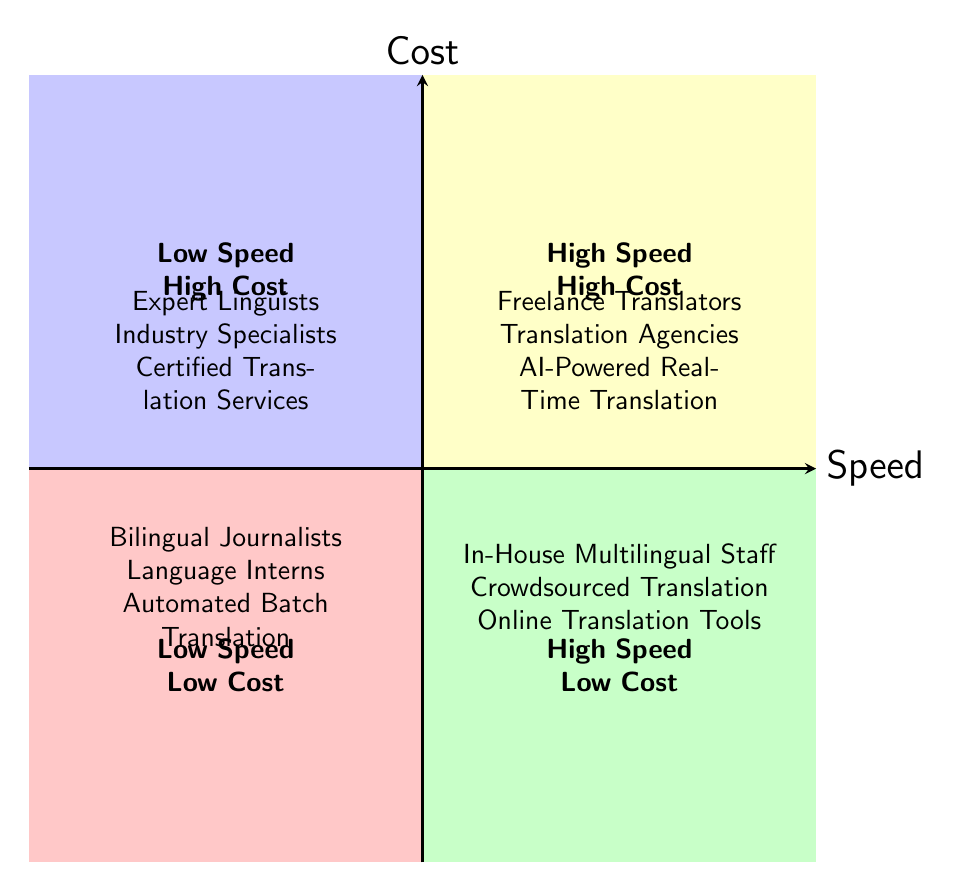What categories are in the High Speed - Low Cost quadrant? The High Speed - Low Cost quadrant contains three categories: In-House Multilingual Staff, Crowdsourced Translation, and Online Translation Tools. This is determined by the provided data for that specific quadrant.
Answer: In-House Multilingual Staff, Crowdsourced Translation, Online Translation Tools Which quadrant contains Expert Linguists? Expert Linguists are located in the Low Speed - High Cost quadrant. This can be derived from the data provided, as Expert Linguists only appear in the Low Speed - High Cost section.
Answer: Low Speed - High Cost How many categories are in the High Speed - High Cost quadrant? The High Speed - High Cost quadrant has three categories: Freelance Translators, Translation Agencies, and AI-Powered Real-Time Translation. Counting these, we can confirm the total is three.
Answer: 3 What is the main difference between the Low Cost quadrants? The main difference is speed: the Low Speed - Low Cost quadrant includes Bilingual Journalists, Language Interns, and Automated Batch Translation, while the High Speed - Low Cost quadrant includes In-House Multilingual Staff, Crowdsourced Translation, and Online Translation Tools. This is based on the grouping of categories within the respective quadrants.
Answer: Speed Which translation method has the highest cost but low speed? The translation methods with the highest cost but low speed are listed under Low Speed - High Cost and include Expert Linguists, Industry Specialists, and Certified Translation Services. These are confirmed as they appear in that quadrant defined by the cost and speed criteria.
Answer: Expert Linguists, Industry Specialists, Certified Translation Services How many total categories are represented in the diagram? The total number of categories represented in the diagram is twelve. This is calculated by summing all categories present in each quadrant: three in each of the High Speed quadrants and three in each of the Low Speed quadrants, leading to a total of twelve.
Answer: 12 Which quadrant contains the fastest translation methods? The quadrant with the fastest translation methods is the High Speed - High Cost quadrant, which includes Freelance Translators, Translation Agencies, and AI-Powered Real-Time Translation. This is analyzed through the positioning of the categories based on their cost and speed attributes.
Answer: High Speed - High Cost What is a key characteristic of categories in the Low Speed quadrants? The key characteristic of the categories in both Low Speed quadrants is that they either involve higher costs (Low Speed - High Cost) or are more affordable but slower (Low Speed - Low Cost). This is understood by examining the definitions of quadrants in terms of speed and cost.
Answer: Cost and Speed 